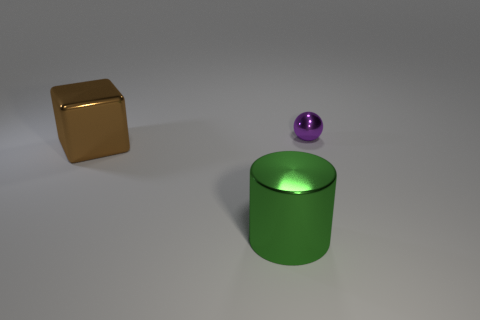Add 3 small purple balls. How many objects exist? 6 Subtract all blocks. How many objects are left? 2 Add 1 big brown metal cubes. How many big brown metal cubes exist? 2 Subtract 0 yellow spheres. How many objects are left? 3 Subtract all big cylinders. Subtract all green things. How many objects are left? 1 Add 3 purple shiny balls. How many purple shiny balls are left? 4 